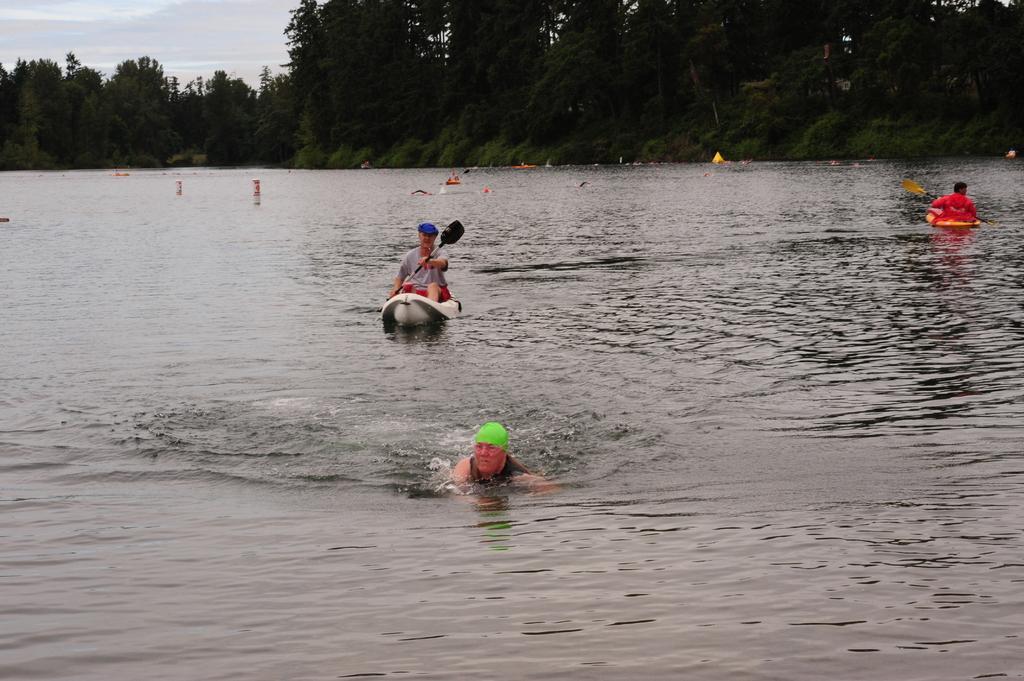In one or two sentences, can you explain what this image depicts? In this image we can see water. And a person wearing cap is in the water. And there are two boats. On that persons are sitting. They are holding paddles. Also there are few other items on the water. In the background there are trees and sky. 